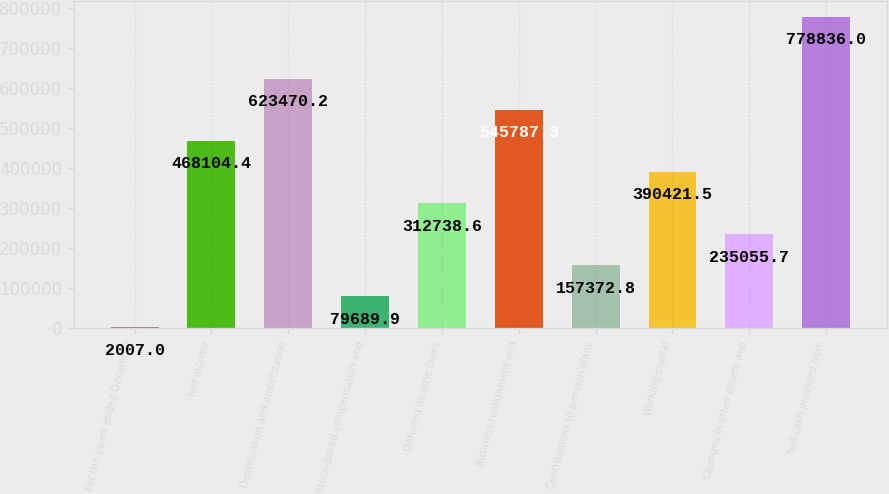Convert chart. <chart><loc_0><loc_0><loc_500><loc_500><bar_chart><fcel>For the years ended December<fcel>Net income<fcel>Depreciation and amortization<fcel>Stock-based compensation and<fcel>Deferred income taxes<fcel>Business realignment and<fcel>Contributions to pension plans<fcel>Working capital<fcel>Changes in other assets and<fcel>Net cash provided from<nl><fcel>2007<fcel>468104<fcel>623470<fcel>79689.9<fcel>312739<fcel>545787<fcel>157373<fcel>390422<fcel>235056<fcel>778836<nl></chart> 